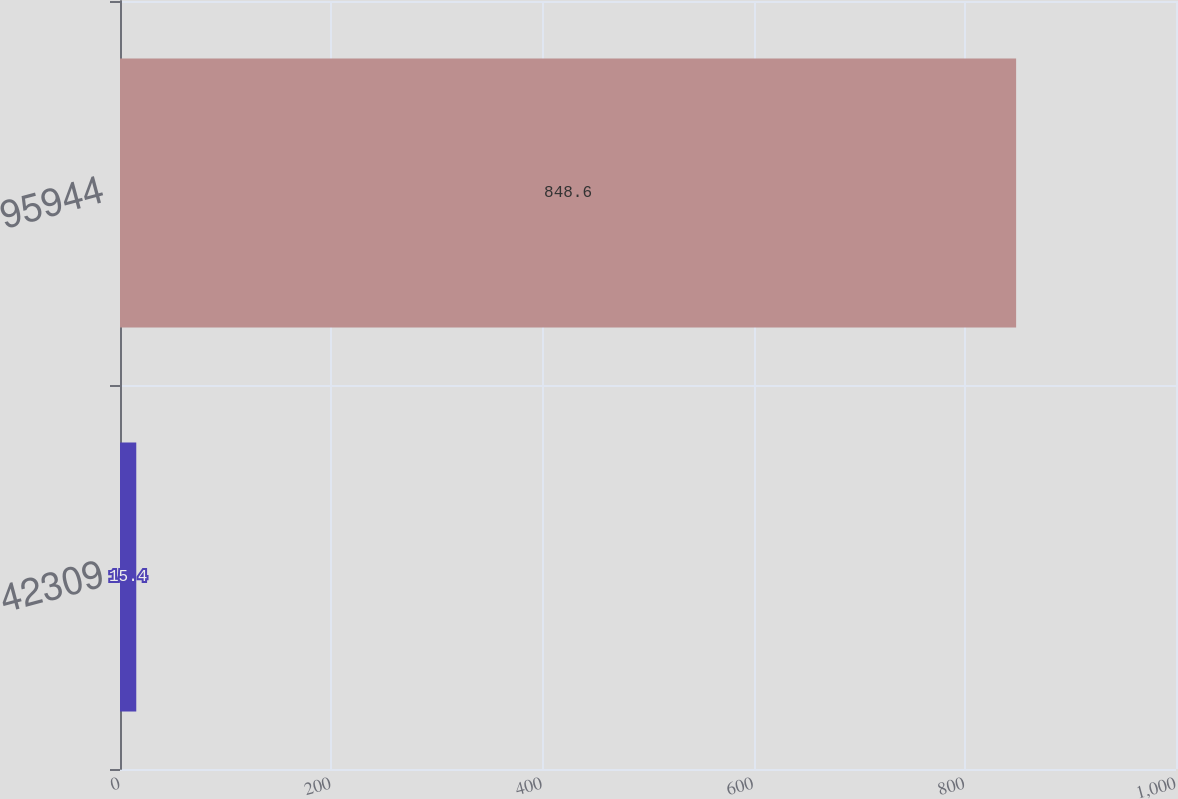<chart> <loc_0><loc_0><loc_500><loc_500><bar_chart><fcel>42309<fcel>95944<nl><fcel>15.4<fcel>848.6<nl></chart> 